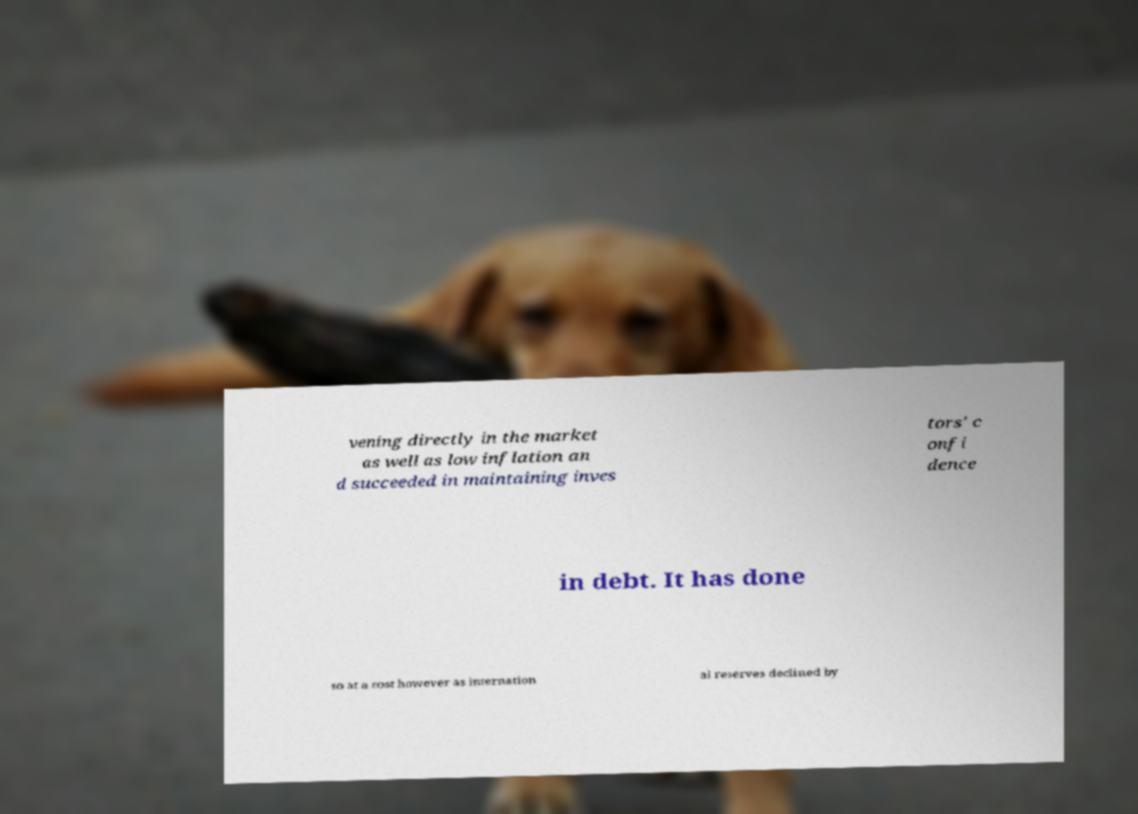Please read and relay the text visible in this image. What does it say? vening directly in the market as well as low inflation an d succeeded in maintaining inves tors' c onfi dence in debt. It has done so at a cost however as internation al reserves declined by 